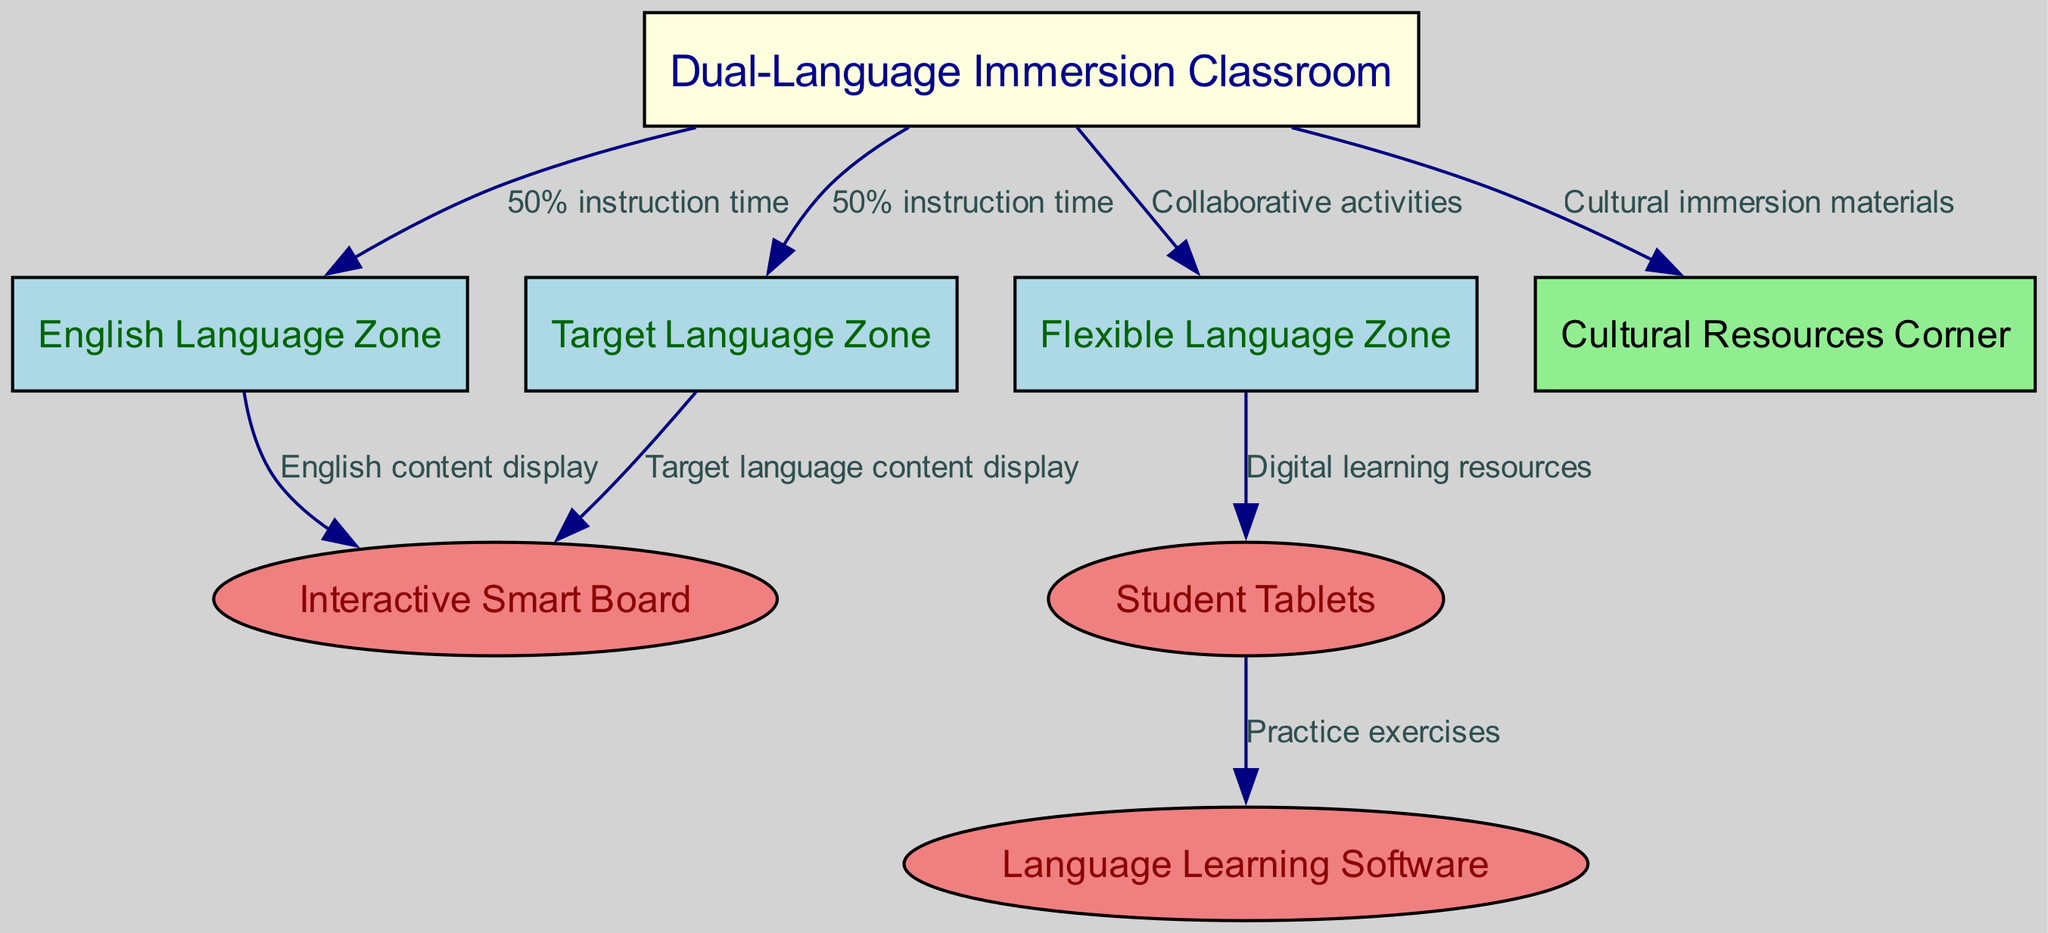What is the main focus of the classroom? The diagram indicates that the main focus of the classroom is the "Dual-Language Immersion Classroom," which serves as the central node from which all other zones and resources are connected.
Answer: Dual-Language Immersion Classroom How many zones are there in the classroom? The diagram shows three distinct language zones: the English Language Zone, Target Language Zone, and Flexible Language Zone. Hence, counting these gives a total of three zones.
Answer: 3 What percentage of instruction time is allotted to the English Language Zone? The edge connecting the classroom to the English Language Zone specifies that 50% of the instruction time is allocated here.
Answer: 50% What connects the Flexible Language Zone to the Student Tablets? The edge indicating a connection between the Flexible Language Zone and Student Tablets states that it is for "Digital learning resources," demonstrating what utilizes these tablets within that zone.
Answer: Digital learning resources Which resource provides cultural immersion materials? The diagram features a node labeled "Cultural Resources Corner," connected directly to the classroom, signifying this is where cultural immersion materials are available and accessed.
Answer: Cultural Resources Corner What is used to display English content? The edge from the English Language Zone to the Interactive Smart Board indicates that this board is used for "English content display," presenting the specific content focus of this resource.
Answer: Interactive Smart Board Which area is dedicated to practice exercises? The connection from Student Tablets to the Language Learning Software node shows that the software is utilized for "Practice exercises," indicating its functional role in this setup.
Answer: Language Learning Software What type of educational technology is highlighted in the classroom? The diagram includes nodes for both the "Interactive Smart Board" and "Student Tablets," showcasing the integration of modern educational technology into the learning environment.
Answer: Educational technology Which zone supports collaborative activities? The edge from the classroom to the Flexible Language Zone specifies the connection for "Collaborative activities," indicating this zone is specifically intended for group work and interactions.
Answer: Flexible Language Zone 